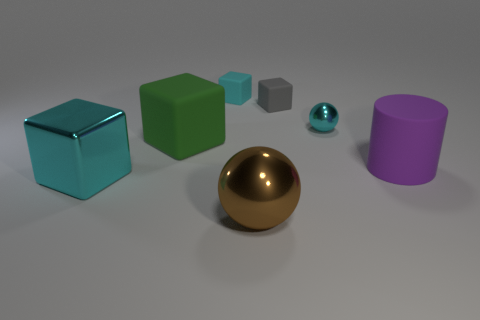Are there any tiny cyan cubes?
Offer a very short reply. Yes. Does the big brown object have the same shape as the cyan metal object that is behind the large metal cube?
Your answer should be compact. Yes. What color is the large matte thing that is to the left of the large object that is to the right of the cyan thing right of the brown shiny thing?
Offer a very short reply. Green. Are there any large green rubber blocks to the right of the large brown shiny sphere?
Ensure brevity in your answer.  No. What size is the matte cube that is the same color as the tiny metallic object?
Your response must be concise. Small. Is there a small gray object made of the same material as the gray block?
Your answer should be very brief. No. What is the color of the tiny sphere?
Your answer should be very brief. Cyan. Does the metallic object that is in front of the big shiny block have the same shape as the big purple rubber object?
Offer a very short reply. No. What is the shape of the large metallic thing that is on the right side of the big matte thing that is behind the big cylinder that is behind the brown object?
Make the answer very short. Sphere. What material is the cube to the left of the green matte block?
Your answer should be very brief. Metal. 